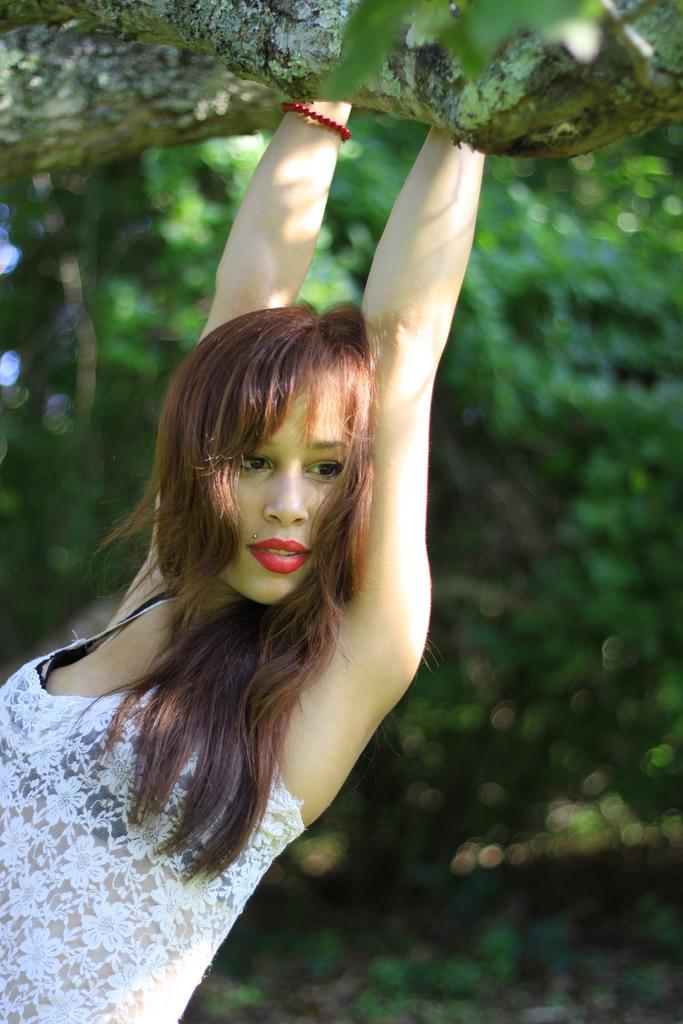What is the main subject of the image? There is a person in the image. What is the person holding in the image? The person is holding a tree trunk. Can you describe the background of the image? The background of the image is blurred. What type of shop can be seen in the background of the image? There is no shop visible in the background of the image; the background is blurred. What is the relationship between the person and the zebra in the image? There is no zebra present in the image. 